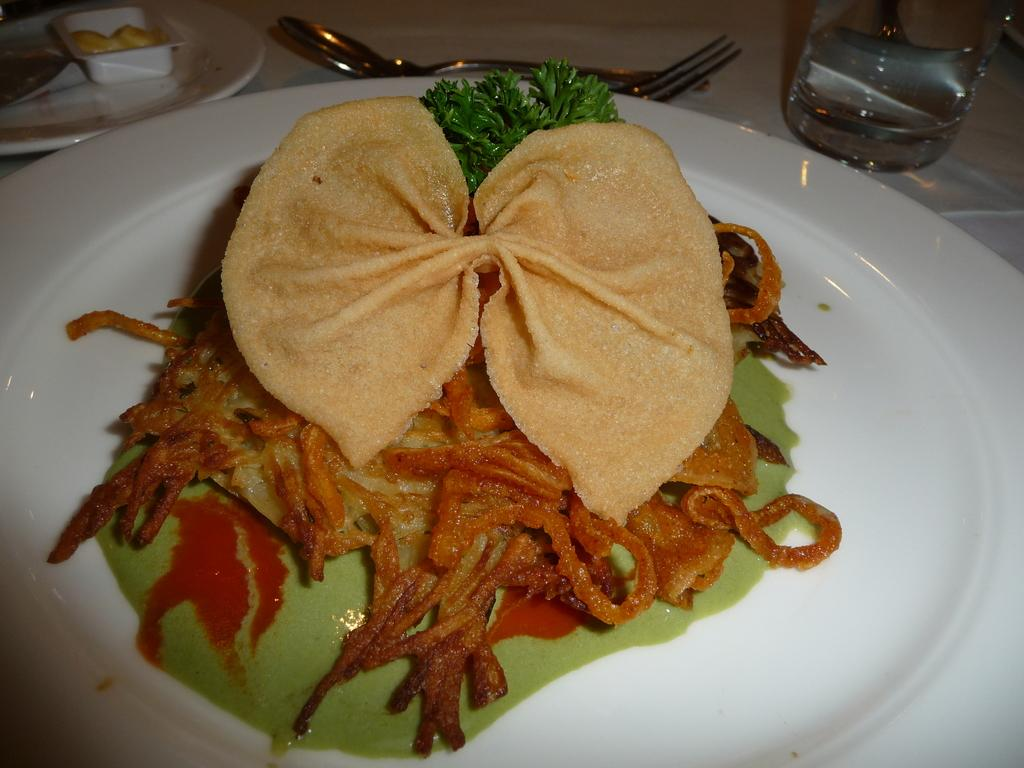What type of food can be seen in the image? The food in the image is in cream and brown color. How is the food presented in the image? The food is in a plate. What color is the plate? The plate is white in color. What year is depicted on the banana in the image? There is no banana present in the image, and therefore no year can be found on it. 